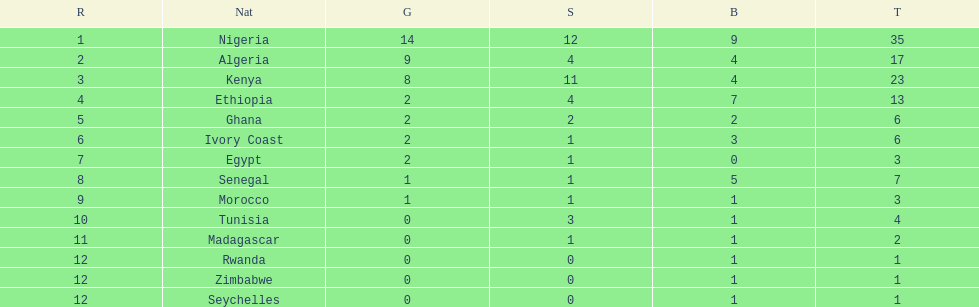The team before algeria Nigeria. Could you help me parse every detail presented in this table? {'header': ['R', 'Nat', 'G', 'S', 'B', 'T'], 'rows': [['1', 'Nigeria', '14', '12', '9', '35'], ['2', 'Algeria', '9', '4', '4', '17'], ['3', 'Kenya', '8', '11', '4', '23'], ['4', 'Ethiopia', '2', '4', '7', '13'], ['5', 'Ghana', '2', '2', '2', '6'], ['6', 'Ivory Coast', '2', '1', '3', '6'], ['7', 'Egypt', '2', '1', '0', '3'], ['8', 'Senegal', '1', '1', '5', '7'], ['9', 'Morocco', '1', '1', '1', '3'], ['10', 'Tunisia', '0', '3', '1', '4'], ['11', 'Madagascar', '0', '1', '1', '2'], ['12', 'Rwanda', '0', '0', '1', '1'], ['12', 'Zimbabwe', '0', '0', '1', '1'], ['12', 'Seychelles', '0', '0', '1', '1']]} 